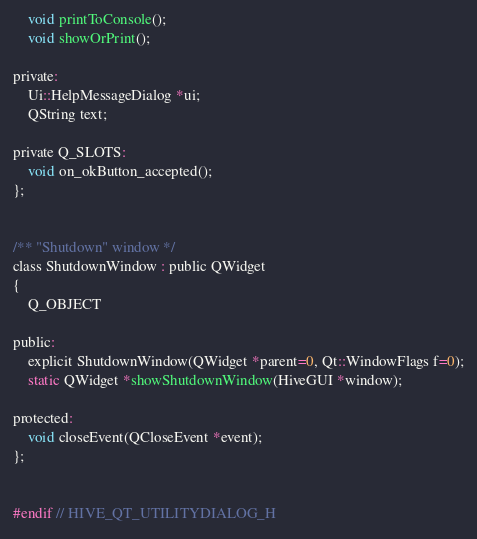<code> <loc_0><loc_0><loc_500><loc_500><_C_>
    void printToConsole();
    void showOrPrint();

private:
    Ui::HelpMessageDialog *ui;
    QString text;

private Q_SLOTS:
    void on_okButton_accepted();
};


/** "Shutdown" window */
class ShutdownWindow : public QWidget
{
    Q_OBJECT

public:
    explicit ShutdownWindow(QWidget *parent=0, Qt::WindowFlags f=0);
    static QWidget *showShutdownWindow(HiveGUI *window);

protected:
    void closeEvent(QCloseEvent *event);
};


#endif // HIVE_QT_UTILITYDIALOG_H
</code> 